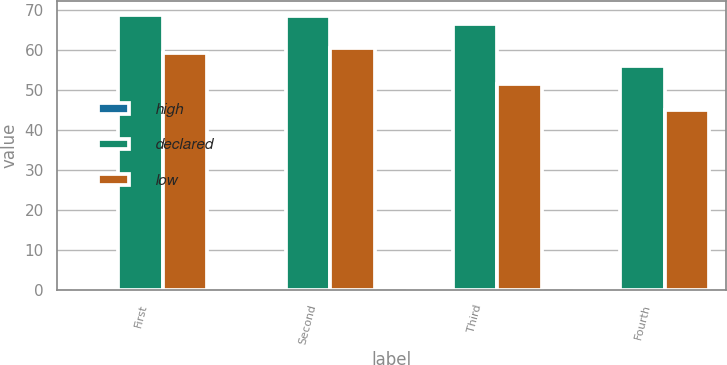Convert chart. <chart><loc_0><loc_0><loc_500><loc_500><stacked_bar_chart><ecel><fcel>First<fcel>Second<fcel>Third<fcel>Fourth<nl><fcel>high<fcel>0.22<fcel>0.22<fcel>0.24<fcel>0.24<nl><fcel>declared<fcel>68.87<fcel>68.44<fcel>66.43<fcel>56.05<nl><fcel>low<fcel>59.33<fcel>60.5<fcel>51.51<fcel>45.04<nl></chart> 